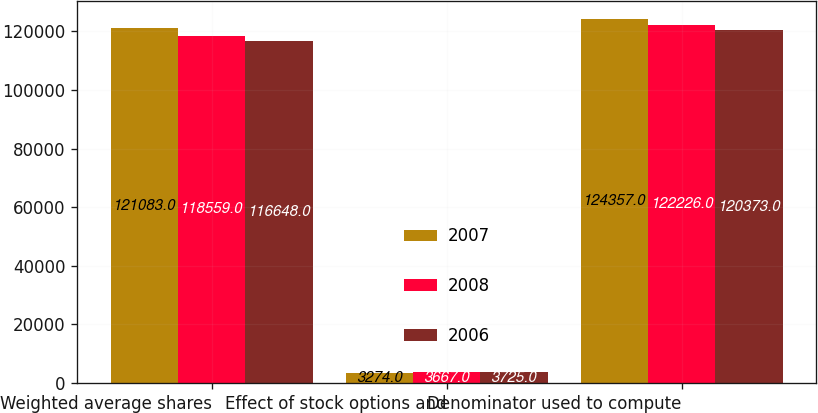<chart> <loc_0><loc_0><loc_500><loc_500><stacked_bar_chart><ecel><fcel>Weighted average shares<fcel>Effect of stock options and<fcel>Denominator used to compute<nl><fcel>2007<fcel>121083<fcel>3274<fcel>124357<nl><fcel>2008<fcel>118559<fcel>3667<fcel>122226<nl><fcel>2006<fcel>116648<fcel>3725<fcel>120373<nl></chart> 